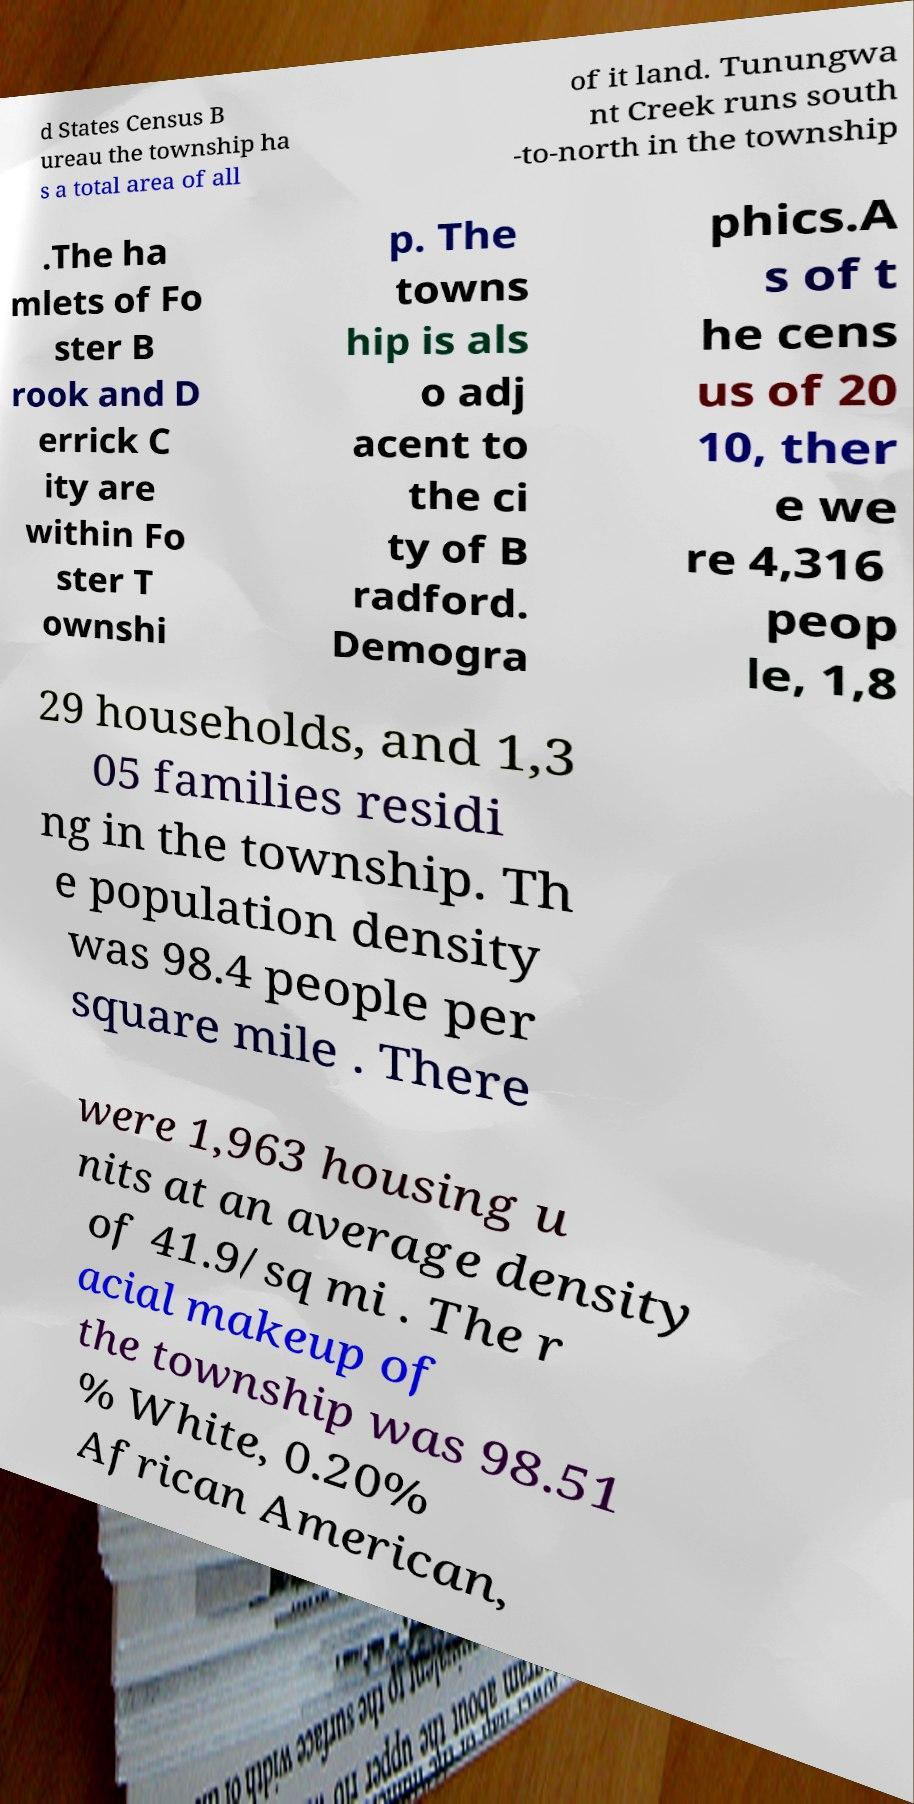Could you assist in decoding the text presented in this image and type it out clearly? d States Census B ureau the township ha s a total area of all of it land. Tunungwa nt Creek runs south -to-north in the township .The ha mlets of Fo ster B rook and D errick C ity are within Fo ster T ownshi p. The towns hip is als o adj acent to the ci ty of B radford. Demogra phics.A s of t he cens us of 20 10, ther e we re 4,316 peop le, 1,8 29 households, and 1,3 05 families residi ng in the township. Th e population density was 98.4 people per square mile . There were 1,963 housing u nits at an average density of 41.9/sq mi . The r acial makeup of the township was 98.51 % White, 0.20% African American, 